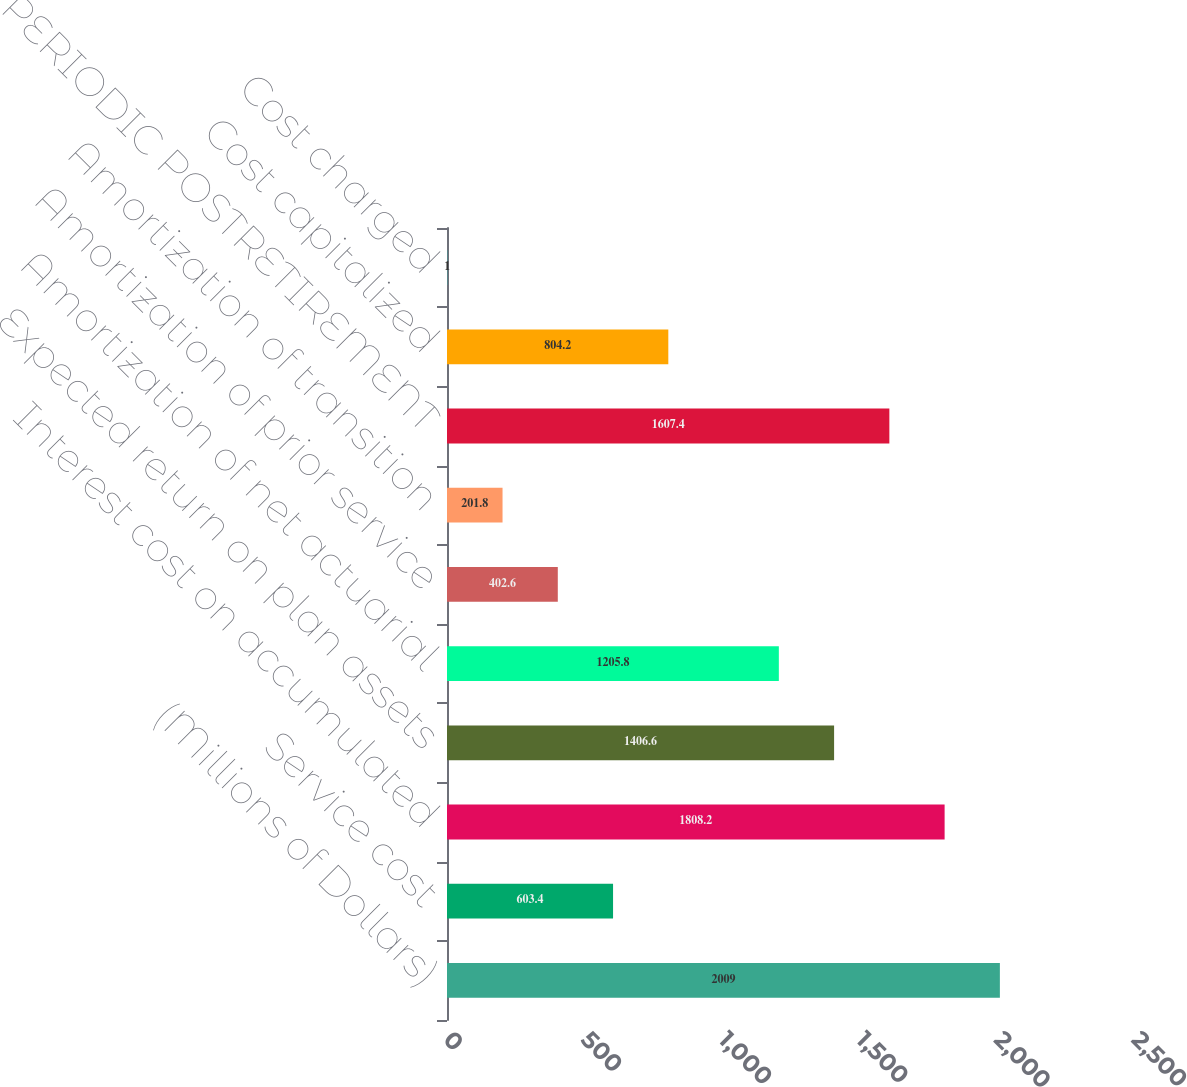<chart> <loc_0><loc_0><loc_500><loc_500><bar_chart><fcel>(Millions of Dollars)<fcel>Service cost<fcel>Interest cost on accumulated<fcel>Expected return on plan assets<fcel>Amortization of net actuarial<fcel>Amortization of prior service<fcel>Amortization of transition<fcel>NET PERIODIC POSTRETIREMENT<fcel>Cost capitalized<fcel>Cost charged<nl><fcel>2009<fcel>603.4<fcel>1808.2<fcel>1406.6<fcel>1205.8<fcel>402.6<fcel>201.8<fcel>1607.4<fcel>804.2<fcel>1<nl></chart> 